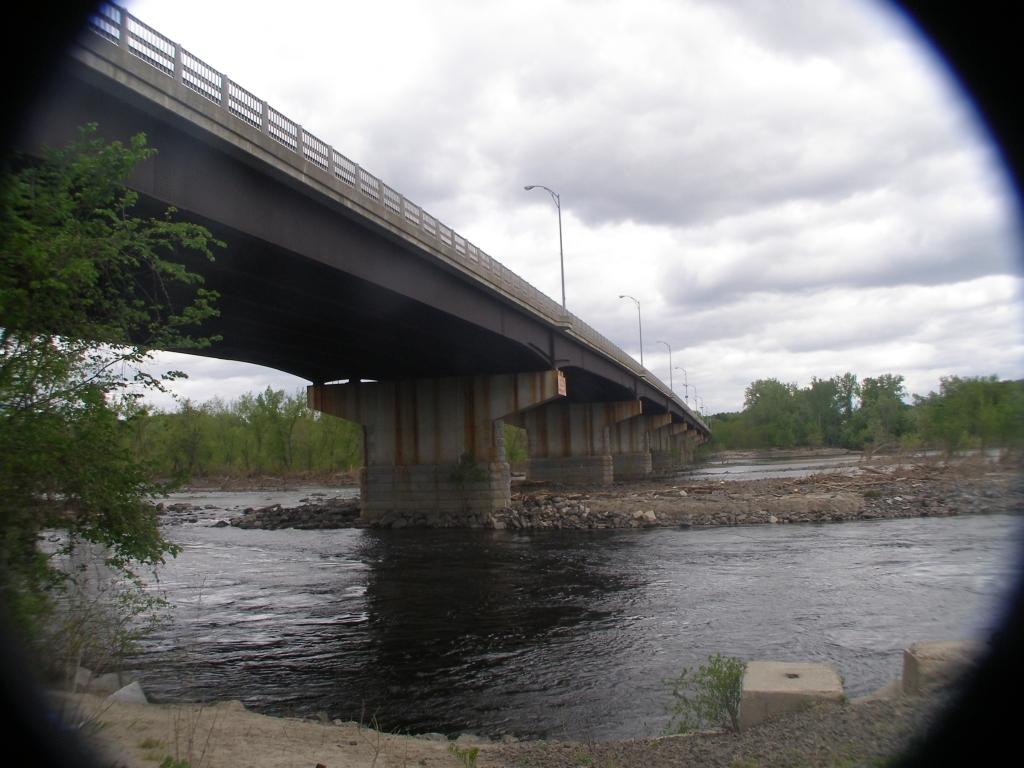What structure can be seen in the image? There is a bridge in the image. What natural element is visible in the image? There is water visible in the image. What type of vegetation can be seen in the background of the image? There are trees in the background of the image. What is visible at the top of the image? There are clouds at the top of the image. What type of lighting is present in the image? There are street lights in the image. What type of bulb is used in the secretary's office in the image? There is no secretary or office present in the image; it features a bridge, water, trees, clouds, and street lights. 